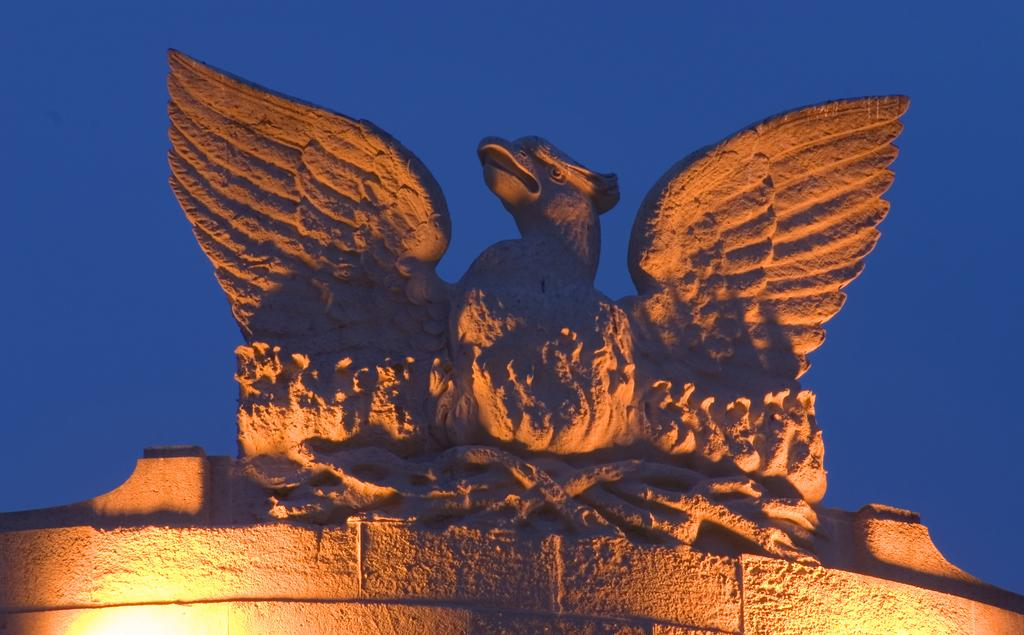What is located at the bottom of the wall in the image? There are lights at the bottom of the wall in the image. What is on top of the wall in the image? There is a statue of a bird on top of the wall. What type of animal is the statue depicting? The statue is of a bird. What can be seen behind the statue in the image? There is sky visible behind the statue. How does the bird in the statue copy the movements of a real bird in the image? The bird in the statue is not capable of copying the movements of a real bird, as it is a static object. What type of cream is being used to smash the statue in the image? There is no cream or smashing activity present in the image; it features a statue of a bird on a wall with lights at the bottom. 